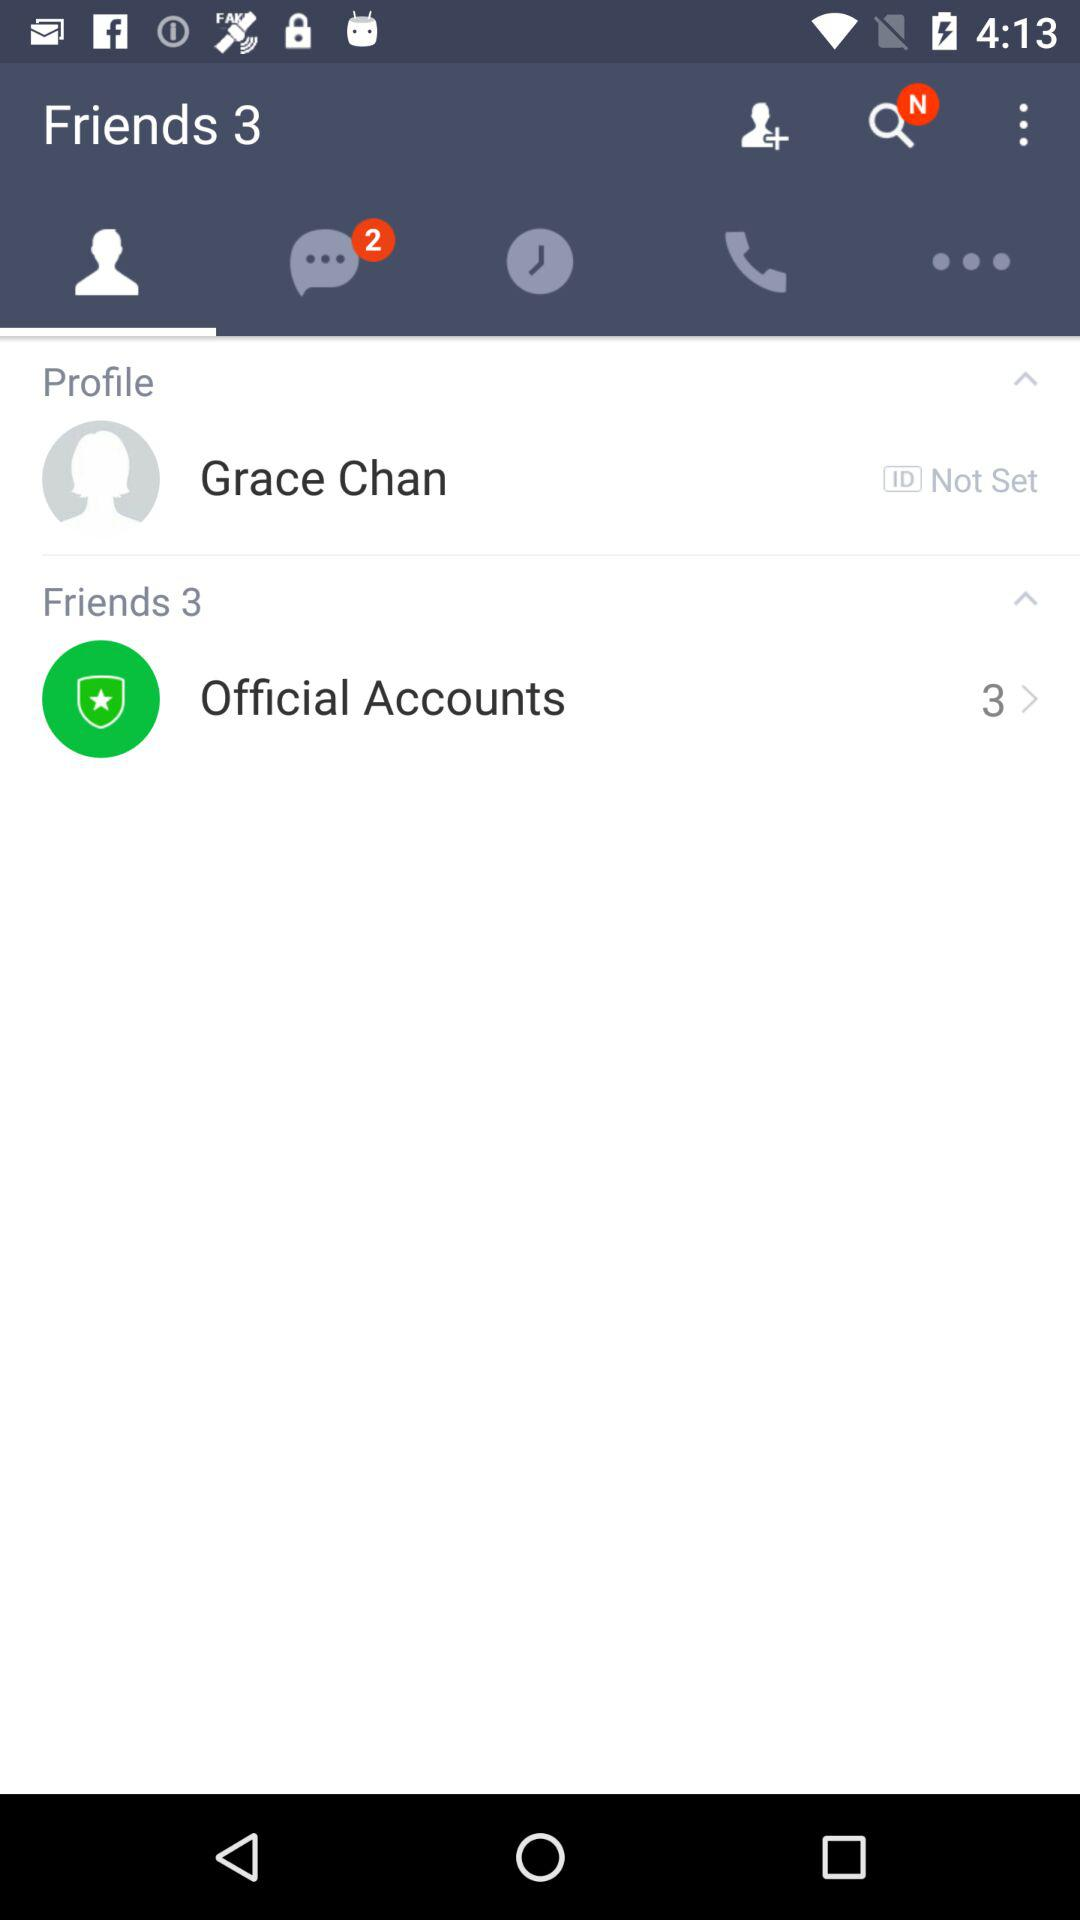What is the profile name? The profile name is Grace Chan. 